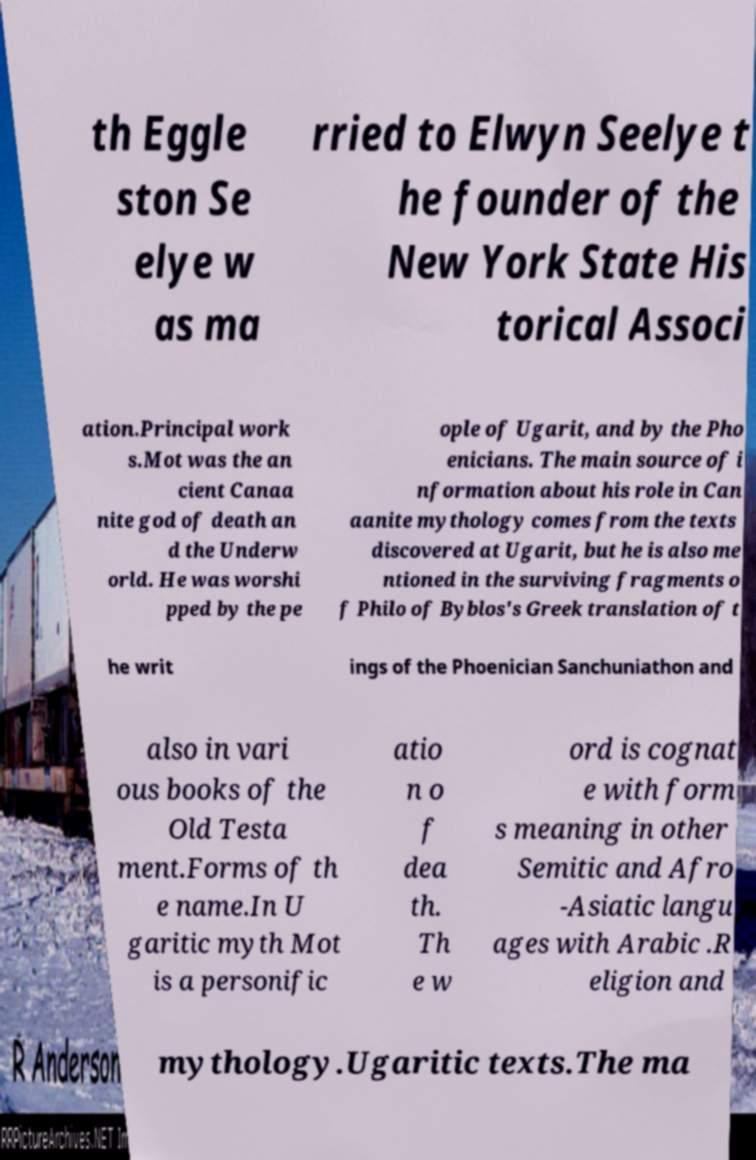There's text embedded in this image that I need extracted. Can you transcribe it verbatim? th Eggle ston Se elye w as ma rried to Elwyn Seelye t he founder of the New York State His torical Associ ation.Principal work s.Mot was the an cient Canaa nite god of death an d the Underw orld. He was worshi pped by the pe ople of Ugarit, and by the Pho enicians. The main source of i nformation about his role in Can aanite mythology comes from the texts discovered at Ugarit, but he is also me ntioned in the surviving fragments o f Philo of Byblos's Greek translation of t he writ ings of the Phoenician Sanchuniathon and also in vari ous books of the Old Testa ment.Forms of th e name.In U garitic myth Mot is a personific atio n o f dea th. Th e w ord is cognat e with form s meaning in other Semitic and Afro -Asiatic langu ages with Arabic .R eligion and mythology.Ugaritic texts.The ma 